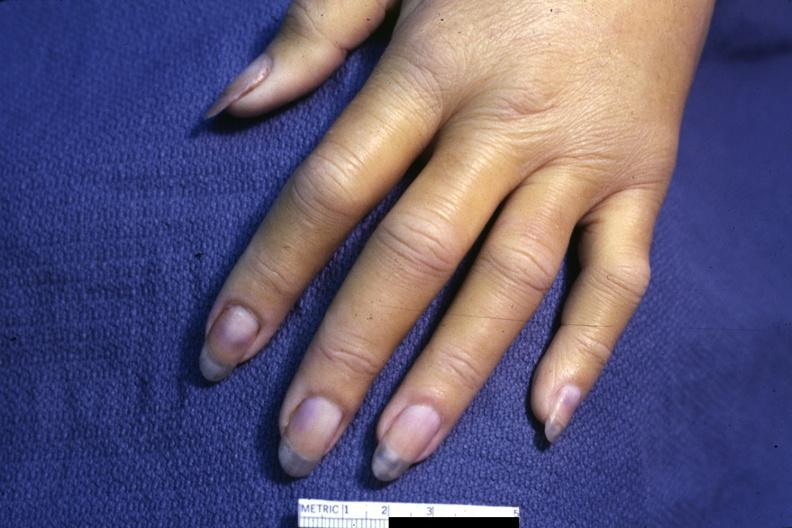what does case of dic not bad photo require?
Answer the question using a single word or phrase. Dark room to see subtle distal phalangeal cyanosis 